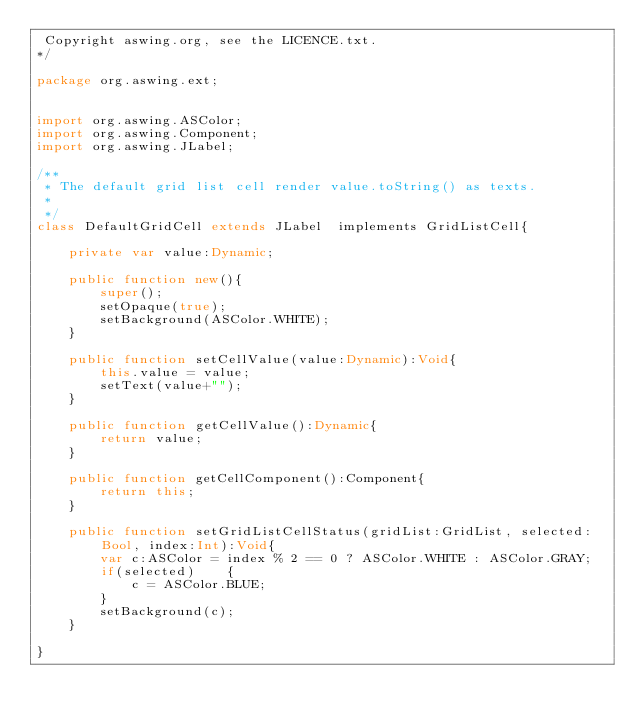Convert code to text. <code><loc_0><loc_0><loc_500><loc_500><_Haxe_> Copyright aswing.org, see the LICENCE.txt.
*/

package org.aswing.ext;


import org.aswing.ASColor;
import org.aswing.Component;
import org.aswing.JLabel;

/**
 * The default grid list cell render value.toString() as texts.
 * 
 */
class DefaultGridCell extends JLabel  implements GridListCell{
	
	private var value:Dynamic;
	
	public function new(){
		super();
		setOpaque(true);
		setBackground(ASColor.WHITE);
	}
	
	public function setCellValue(value:Dynamic):Void{
		this.value = value;
		setText(value+"");
	}
	
	public function getCellValue():Dynamic{
		return value;
	}
				
	public function getCellComponent():Component{
		return this;
	}
	
	public function setGridListCellStatus(gridList:GridList, selected:Bool, index:Int):Void{
		var c:ASColor = index % 2 == 0 ? ASColor.WHITE : ASColor.GRAY;
		if(selected)	{
			c = ASColor.BLUE;
		}
		setBackground(c);
	}
	
}</code> 